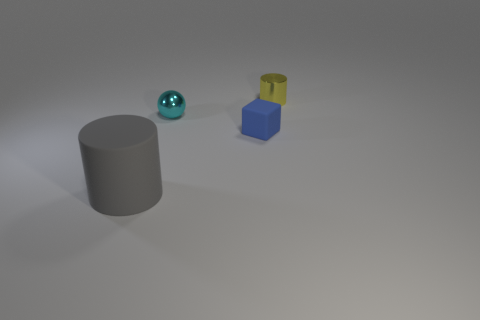There is a metal object that is in front of the tiny yellow cylinder; what number of small blue blocks are left of it? 0 